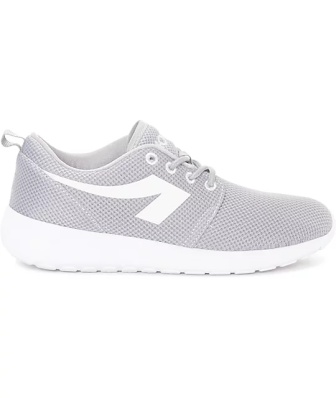Can you elaborate on the elements of the picture provided?
 The image presents a single sneaker, cast in shades of gray and white. The sneaker is oriented to the left, standing out against a stark white background. The sole of the sneaker is white, contrasting with the gray upper. A white stripe adorns the side of the upper, matching the white laces that crisscross over the top. At the heel of the sneaker, a pull tab is visible, potentially aiding in the ease of wearing the shoe. The sneaker appears to be stationary, with no indication of movement or action. The relative position of the sneaker to the background and other objects cannot be determined as the sneaker is the sole focus of the image. There is no text present in the image. 